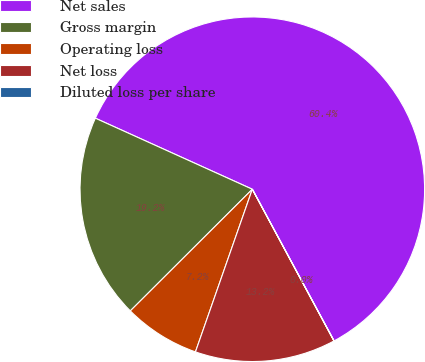Convert chart to OTSL. <chart><loc_0><loc_0><loc_500><loc_500><pie_chart><fcel>Net sales<fcel>Gross margin<fcel>Operating loss<fcel>Net loss<fcel>Diluted loss per share<nl><fcel>60.36%<fcel>19.24%<fcel>7.17%<fcel>13.21%<fcel>0.01%<nl></chart> 